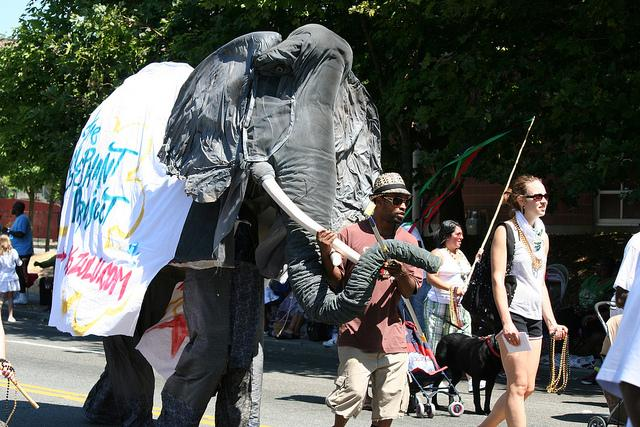What is the ancestral animal of the animal represented here? mammoth 